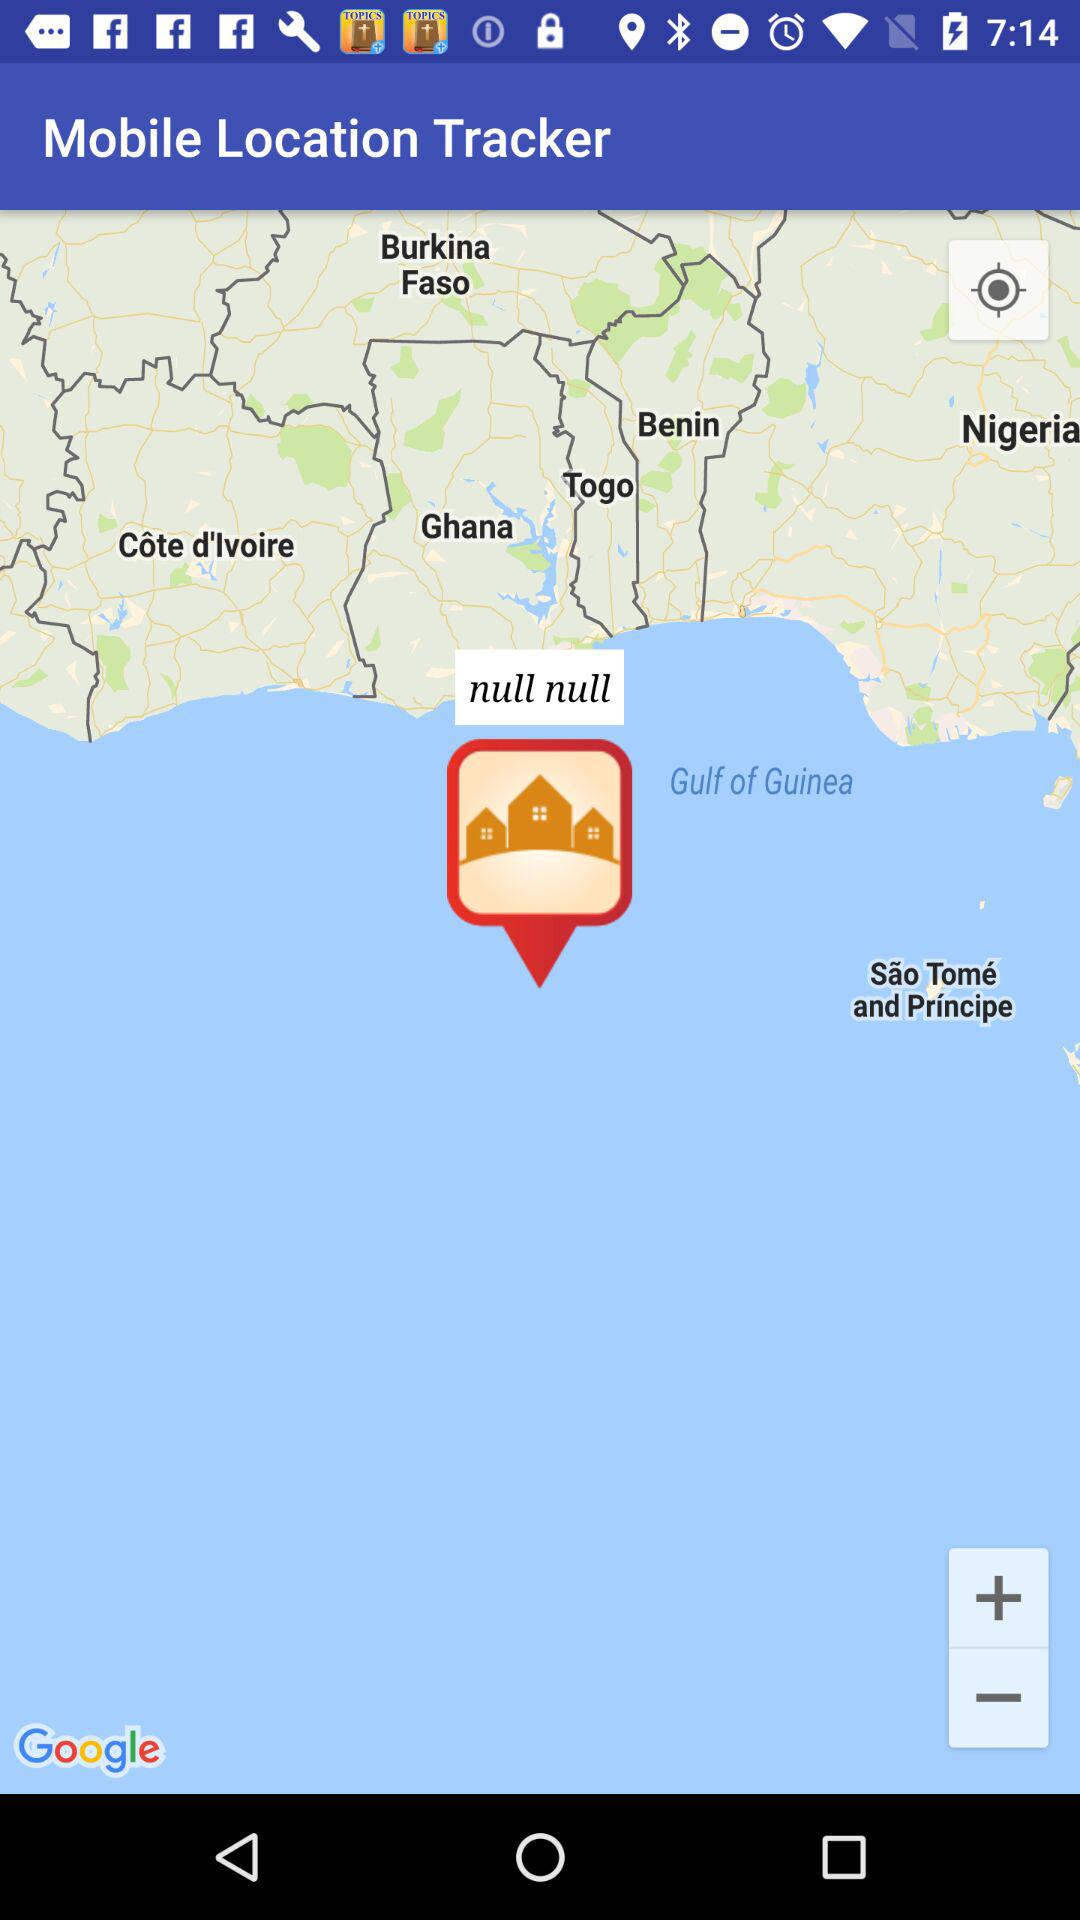What is the application name? The application name is "Mobile Location Tracker". 